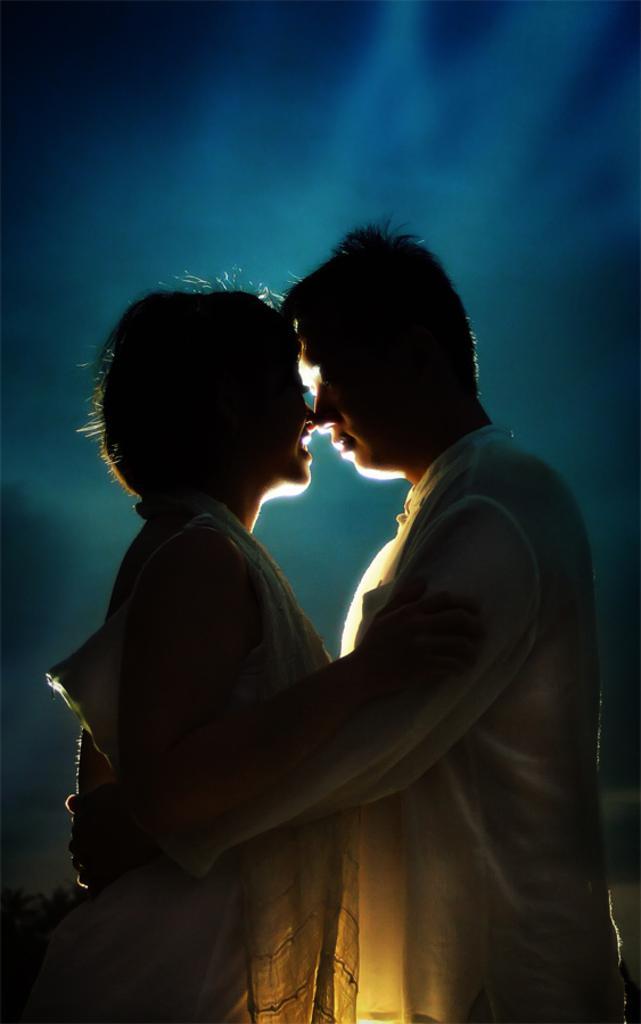In one or two sentences, can you explain what this image depicts? In this picture there are two people standing, among them there's a man holding a woman. In the background of the image it is blurry and we can see the sky. 